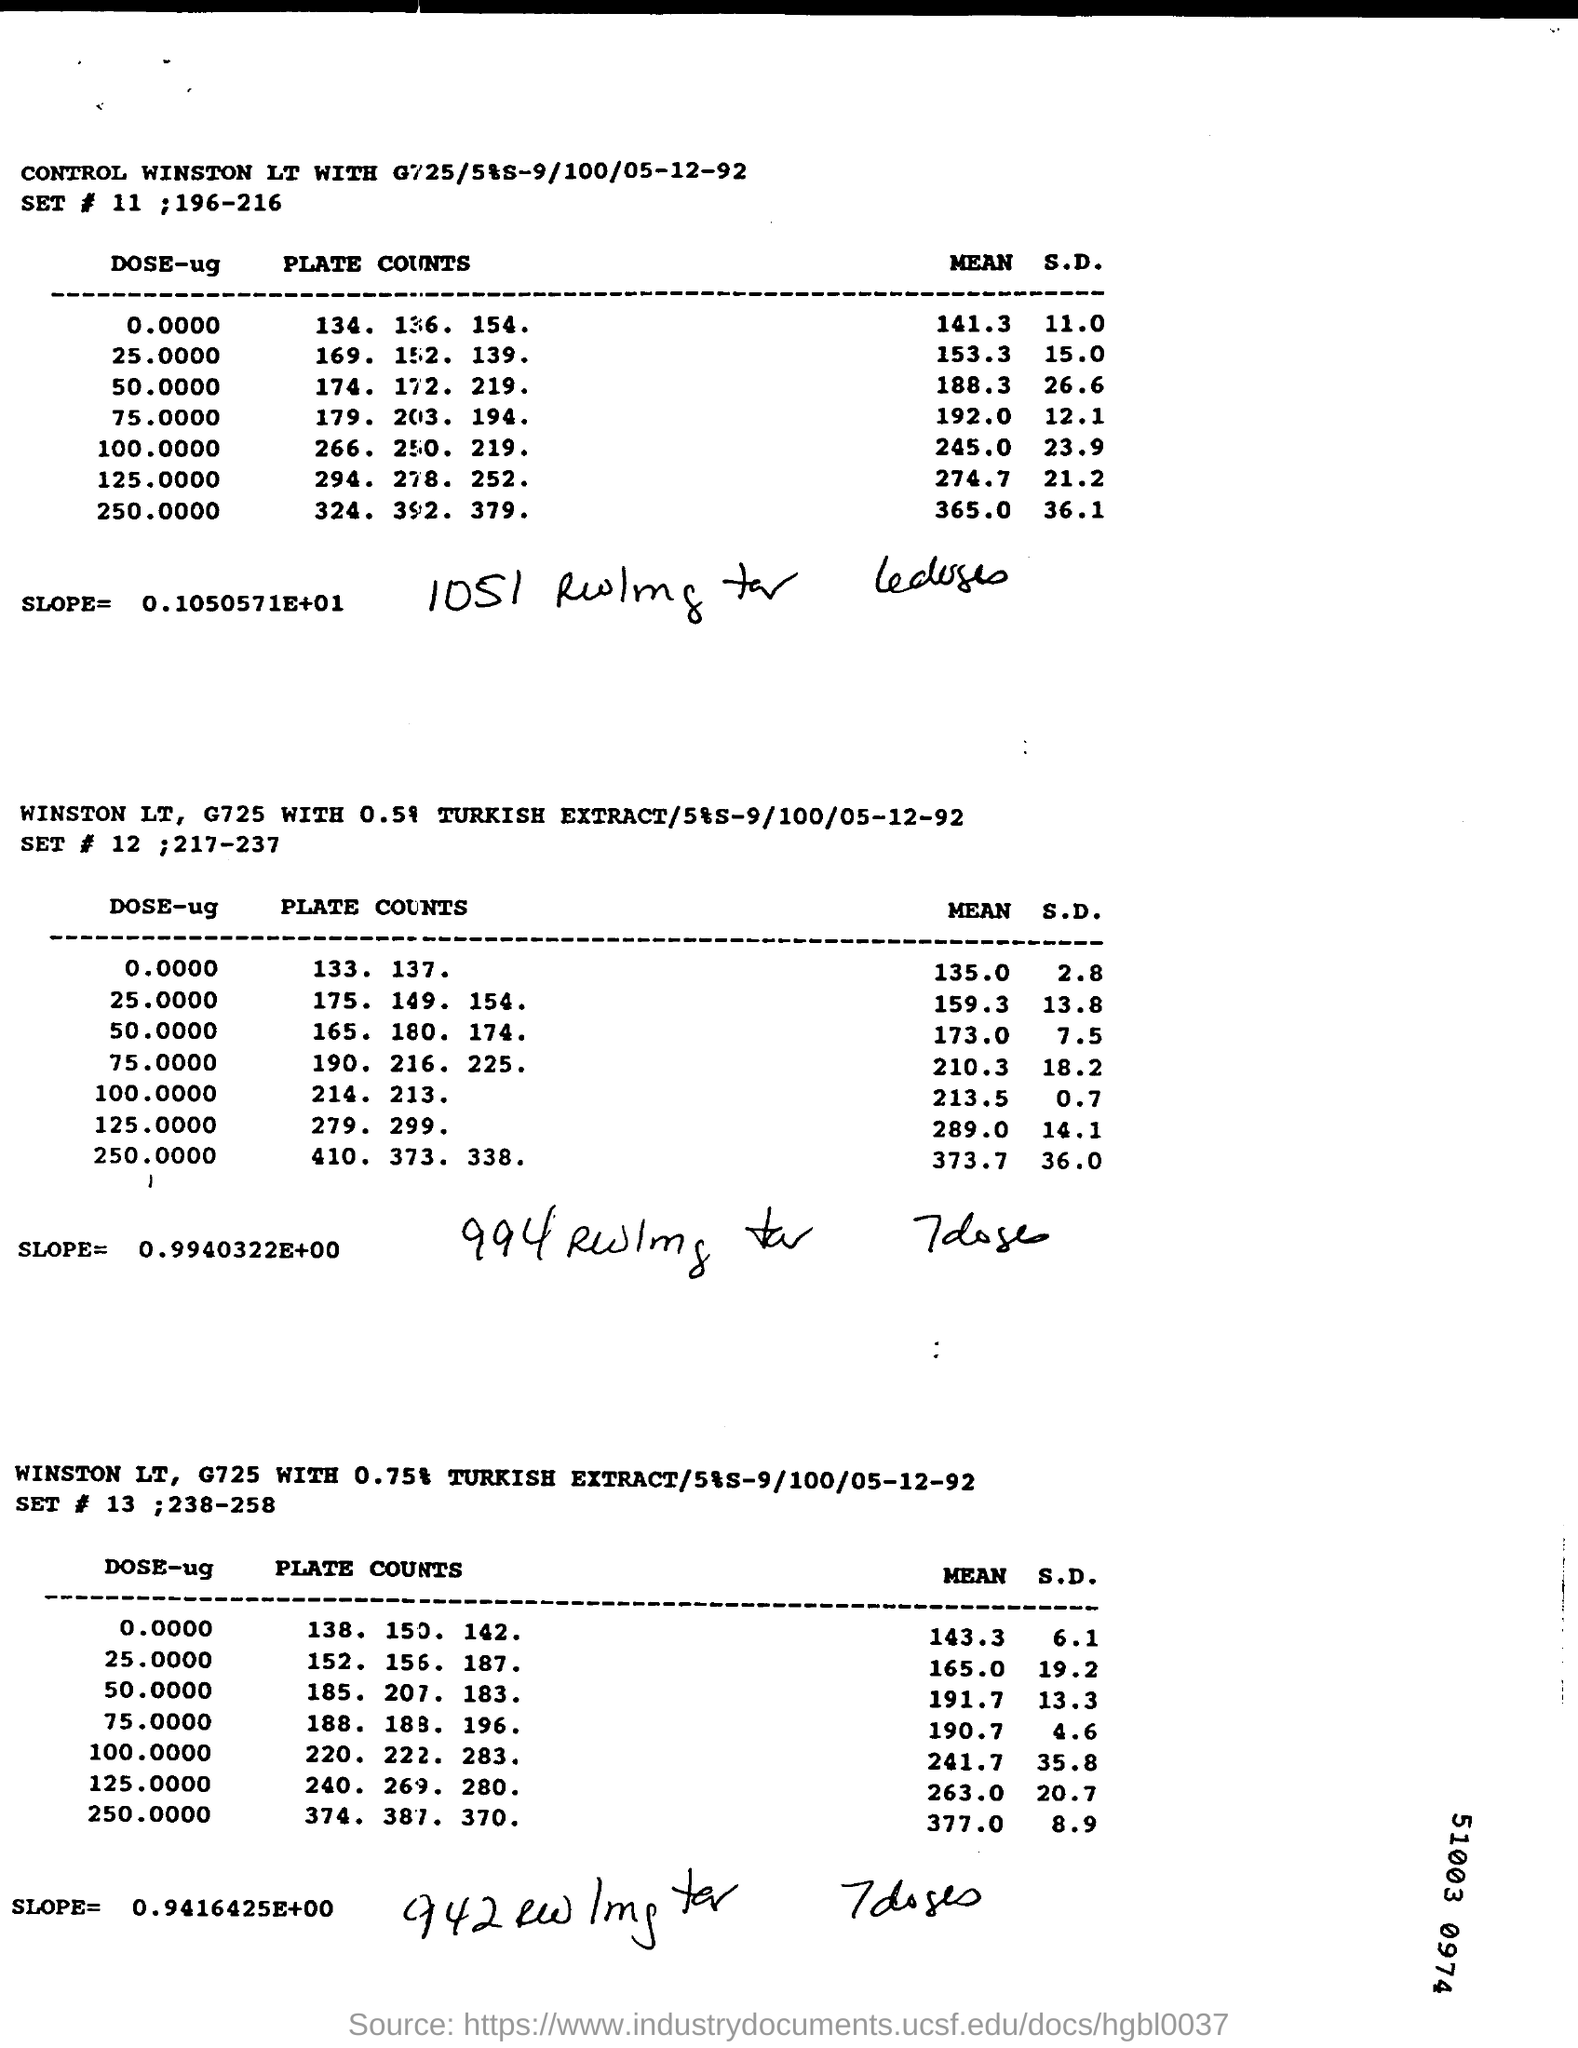What is the slope written under the first Table "SET # 11;196-216" ?
Offer a very short reply. 0.1050571E+01. What is the mean of the first value of DOSE-ug in the table " SET # 11 ; 196-216" ?
Keep it short and to the point. 141.3. 